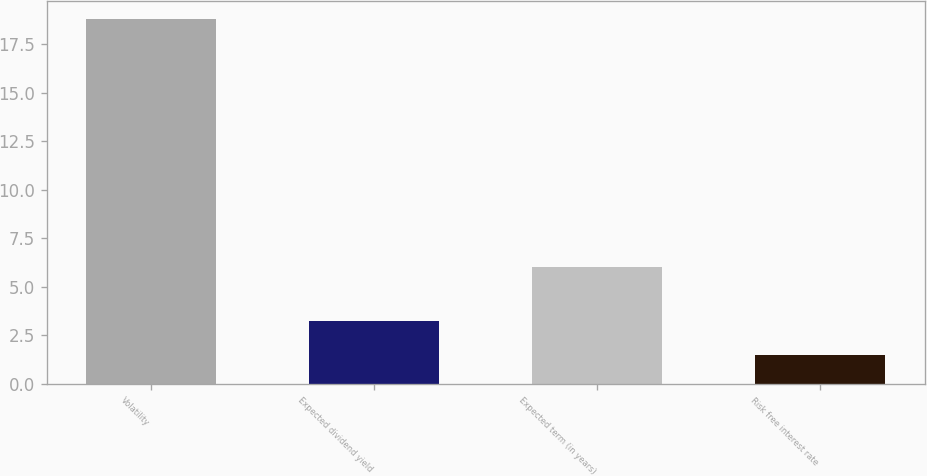<chart> <loc_0><loc_0><loc_500><loc_500><bar_chart><fcel>Volatility<fcel>Expected dividend yield<fcel>Expected term (in years)<fcel>Risk free interest rate<nl><fcel>18.8<fcel>3.23<fcel>6<fcel>1.5<nl></chart> 